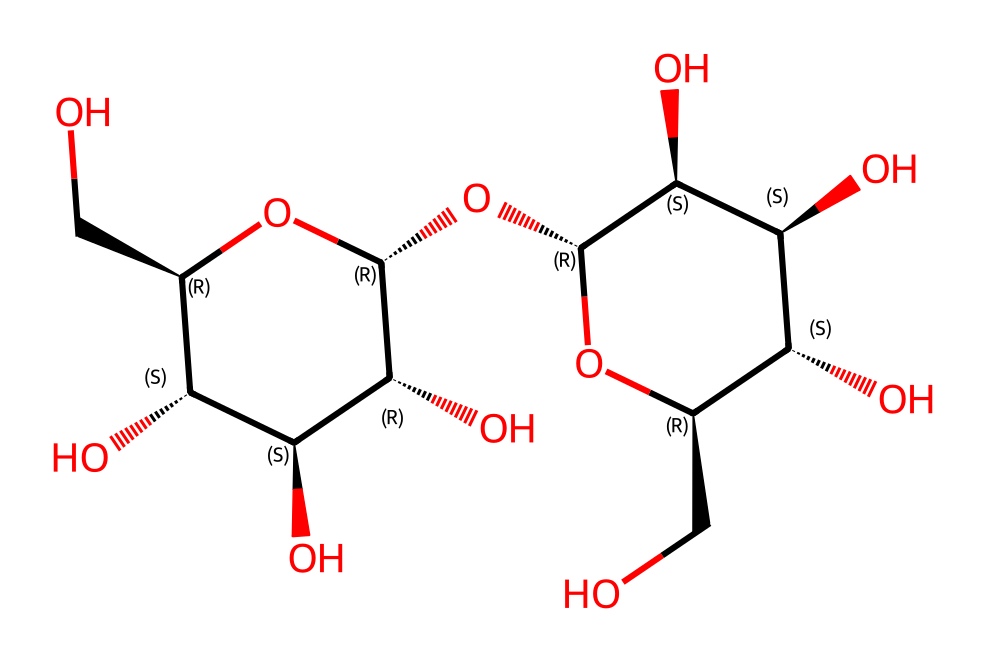What is the molecular formula of the chemical? By analyzing the SMILES representation, we can count each type of atom present in the structure. The molecular formula includes all the carbon (C), hydrogen (H), and oxygen (O) atoms. In this case, there are 12 carbon atoms, 22 hydrogen atoms, and 11 oxygen atoms, giving the formula C12H22O11.
Answer: C12H22O11 How many hydroxyl (–OH) groups are present in the structure? Examining the structure represented in the SMILES, we can identify the hydroxyl groups by looking for "O" that is bonded to a carbon atom with a hydrogen atom. In this case, there are 9 hydroxyl groups present.
Answer: 9 Is this compound a polysaccharide? The presence of multiple monosaccharide units linked together with glycosidic bonds indicates that this compound is a polysaccharide. Given the repeating units of sugar-like structures, it confirms its classification.
Answer: Yes What type of bonding connects the sugar units in this molecule? The bonds connecting the sugar units in this molecule are glycosidic bonds, which are formed from the reaction of hydroxyl groups between monosaccharide units, resulting in polymerization.
Answer: Glycosidic bonds What is the potential application of this nanomaterial in construction? Nanocellulose fibers, due to their high strength-to-weight ratio, low density, and renewability, can be utilized in composite materials, providing strength and sustainability in construction applications.
Answer: Composite materials How does the presence of nanocellulose fibers impact the sustainability of construction materials? Utilizing nanocellulose fibers enhances the sustainability of construction materials by providing a renewable resource that reduces reliance on fossil fuels and lowers the carbon footprint of building materials due to their biodegradable nature.
Answer: Renewable resource What feature of nanocellulose enhances its mechanical properties? The high surface area and strong hydrogen bonding between nanocellulose fibers significantly contribute to enhanced mechanical properties, allowing for better stress distribution and increased material strength.
Answer: High surface area 